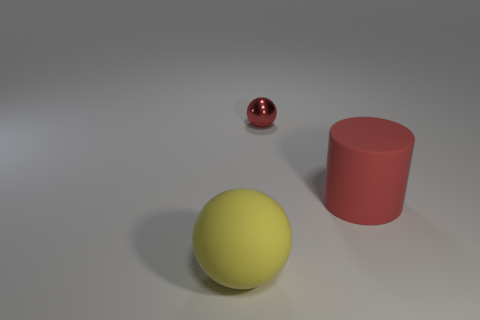Add 2 large matte cylinders. How many objects exist? 5 Subtract all red spheres. How many spheres are left? 1 Subtract 1 cylinders. How many cylinders are left? 0 Subtract all balls. How many objects are left? 1 Subtract all small metal balls. Subtract all yellow matte things. How many objects are left? 1 Add 1 yellow balls. How many yellow balls are left? 2 Add 3 small objects. How many small objects exist? 4 Subtract 1 red cylinders. How many objects are left? 2 Subtract all brown balls. Subtract all red cylinders. How many balls are left? 2 Subtract all yellow blocks. How many red balls are left? 1 